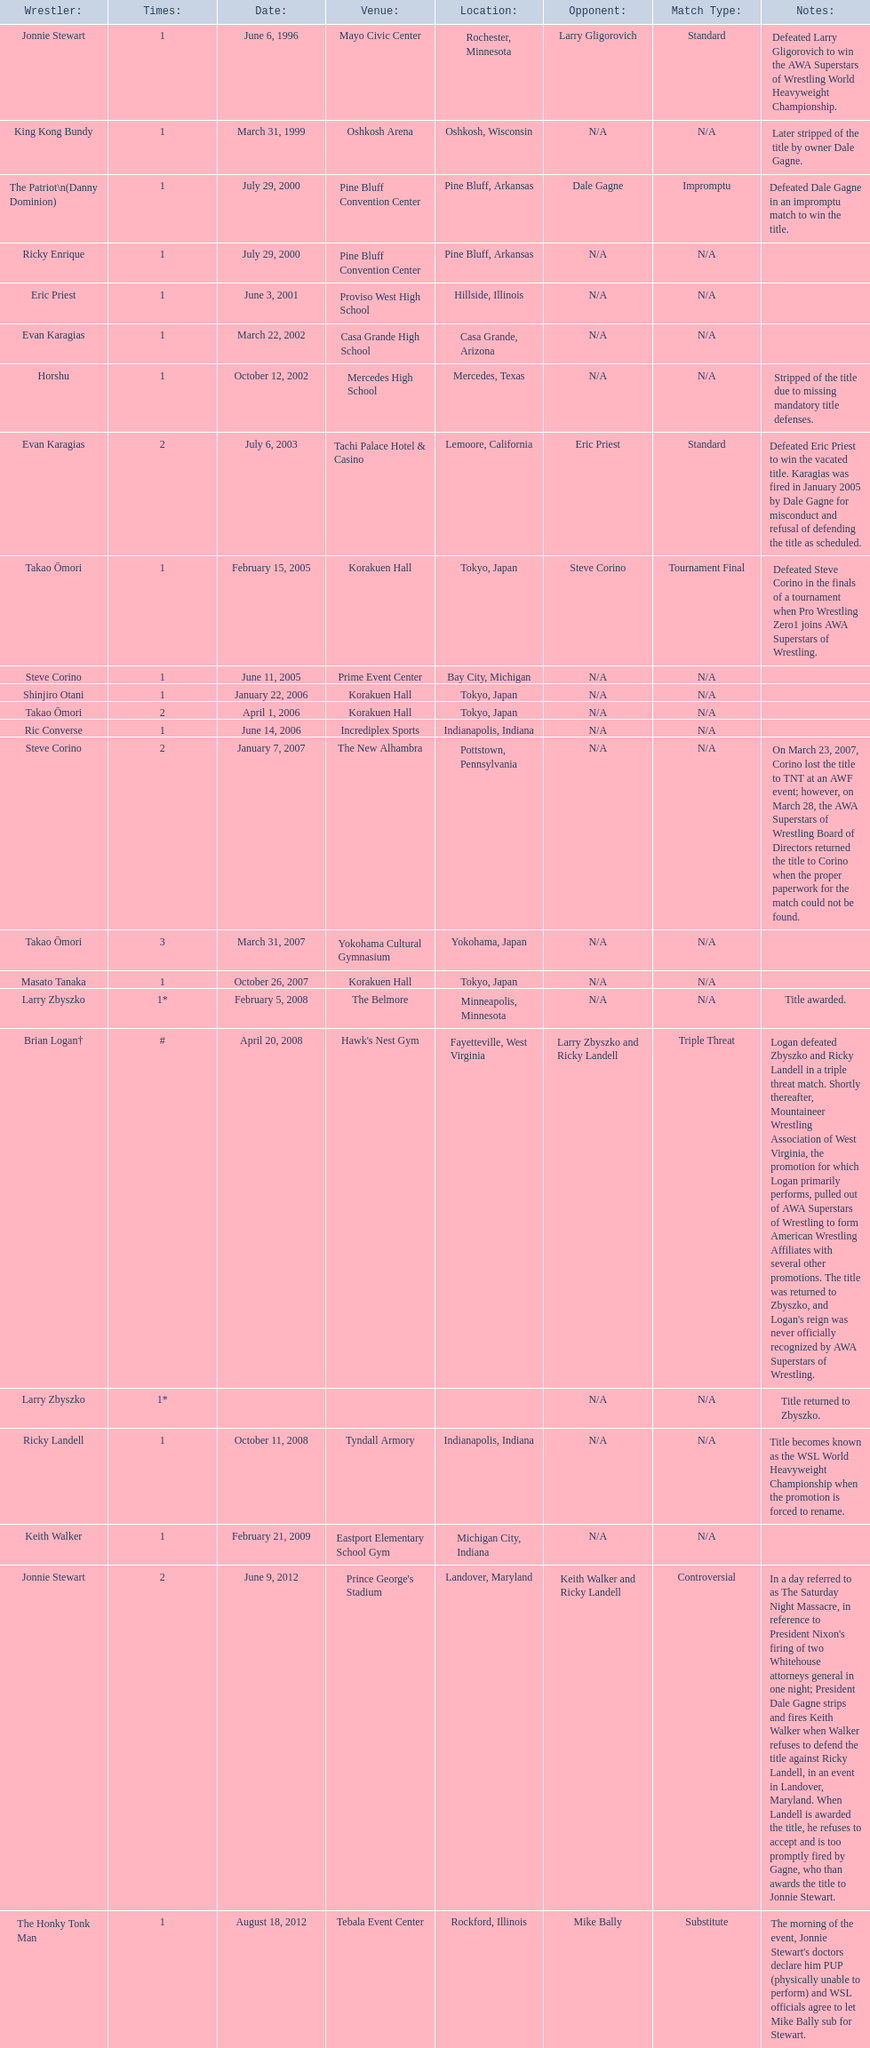Who are all of the wrestlers? Jonnie Stewart, King Kong Bundy, The Patriot\n(Danny Dominion), Ricky Enrique, Eric Priest, Evan Karagias, Horshu, Evan Karagias, Takao Ōmori, Steve Corino, Shinjiro Otani, Takao Ōmori, Ric Converse, Steve Corino, Takao Ōmori, Masato Tanaka, Larry Zbyszko, Brian Logan†, Larry Zbyszko, Ricky Landell, Keith Walker, Jonnie Stewart, The Honky Tonk Man. Where are they from? Rochester, Minnesota, Oshkosh, Wisconsin, Pine Bluff, Arkansas, Pine Bluff, Arkansas, Hillside, Illinois, Casa Grande, Arizona, Mercedes, Texas, Lemoore, California, Tokyo, Japan, Bay City, Michigan, Tokyo, Japan, Tokyo, Japan, Indianapolis, Indiana, Pottstown, Pennsylvania, Yokohama, Japan, Tokyo, Japan, Minneapolis, Minnesota, Fayetteville, West Virginia, , Indianapolis, Indiana, Michigan City, Indiana, Landover, Maryland, Rockford, Illinois. And which of them is from texas? Horshu. 